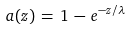Convert formula to latex. <formula><loc_0><loc_0><loc_500><loc_500>a ( z ) \, = \, 1 \, - \, e ^ { - z / \lambda }</formula> 